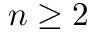Convert formula to latex. <formula><loc_0><loc_0><loc_500><loc_500>n \geq 2</formula> 